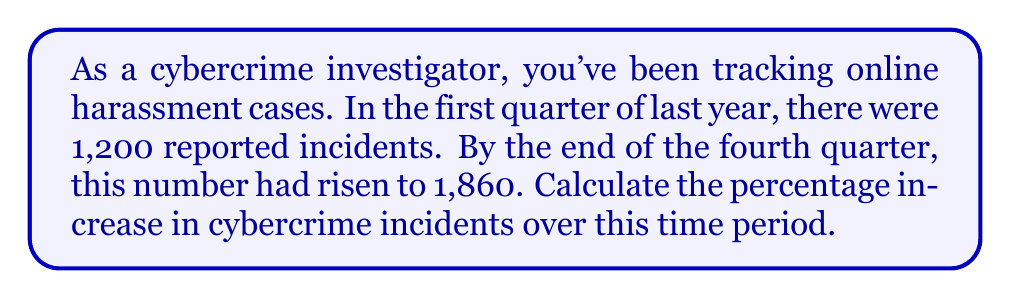Solve this math problem. To calculate the percentage increase, we need to follow these steps:

1. Find the difference between the final and initial values:
   $1,860 - 1,200 = 660$

2. Divide this difference by the initial value:
   $\frac{660}{1,200} = 0.55$

3. Multiply by 100 to convert to a percentage:
   $0.55 \times 100 = 55\%$

The formula for percentage increase is:

$$\text{Percentage Increase} = \frac{\text{Increase}}{\text{Original Amount}} \times 100\%$$

Substituting our values:

$$\text{Percentage Increase} = \frac{1,860 - 1,200}{1,200} \times 100\% = \frac{660}{1,200} \times 100\% = 0.55 \times 100\% = 55\%$$

Therefore, the percentage increase in cybercrime incidents over the given time period is 55%.
Answer: 55% 